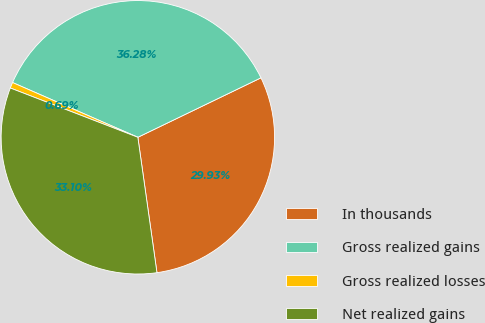<chart> <loc_0><loc_0><loc_500><loc_500><pie_chart><fcel>In thousands<fcel>Gross realized gains<fcel>Gross realized losses<fcel>Net realized gains<nl><fcel>29.93%<fcel>36.28%<fcel>0.69%<fcel>33.1%<nl></chart> 